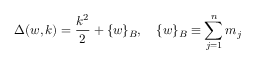Convert formula to latex. <formula><loc_0><loc_0><loc_500><loc_500>\Delta ( w , k ) = \frac { k ^ { 2 } } { 2 } + \{ w \} _ { B } , \quad \{ w \} _ { B } \equiv \sum _ { j = 1 } ^ { n } m _ { j }</formula> 